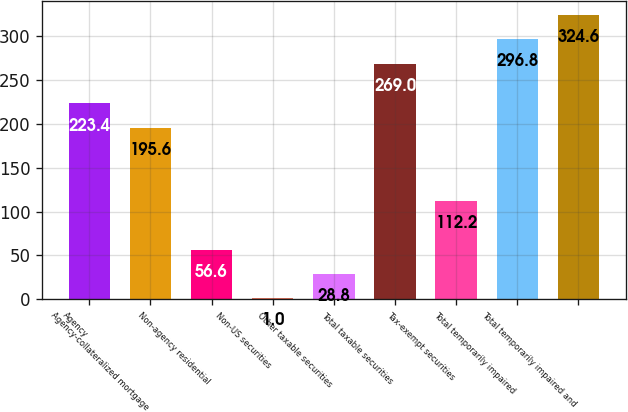<chart> <loc_0><loc_0><loc_500><loc_500><bar_chart><fcel>Agency<fcel>Agency-collateralized mortgage<fcel>Non-agency residential<fcel>Non-US securities<fcel>Other taxable securities<fcel>Total taxable securities<fcel>Tax-exempt securities<fcel>Total temporarily impaired<fcel>Total temporarily impaired and<nl><fcel>223.4<fcel>195.6<fcel>56.6<fcel>1<fcel>28.8<fcel>269<fcel>112.2<fcel>296.8<fcel>324.6<nl></chart> 